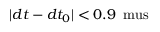Convert formula to latex. <formula><loc_0><loc_0><loc_500><loc_500>| d t - d t _ { 0 } | < 0 . 9 \, \ m u s</formula> 